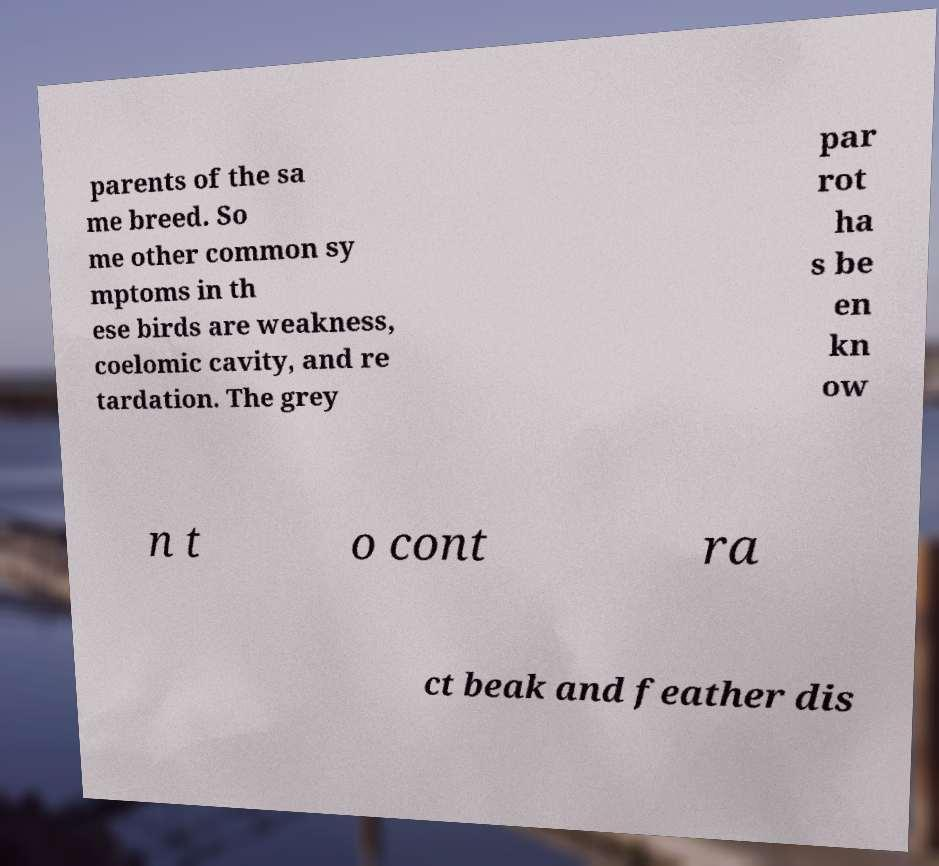There's text embedded in this image that I need extracted. Can you transcribe it verbatim? parents of the sa me breed. So me other common sy mptoms in th ese birds are weakness, coelomic cavity, and re tardation. The grey par rot ha s be en kn ow n t o cont ra ct beak and feather dis 